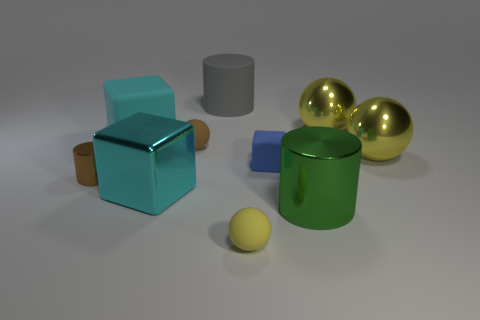Subtract all blue cubes. How many yellow balls are left? 3 Subtract 1 balls. How many balls are left? 3 Subtract all blocks. How many objects are left? 7 Subtract 0 red cubes. How many objects are left? 10 Subtract all tiny cyan metallic cubes. Subtract all large things. How many objects are left? 4 Add 8 cyan shiny blocks. How many cyan shiny blocks are left? 9 Add 4 big green metal cylinders. How many big green metal cylinders exist? 5 